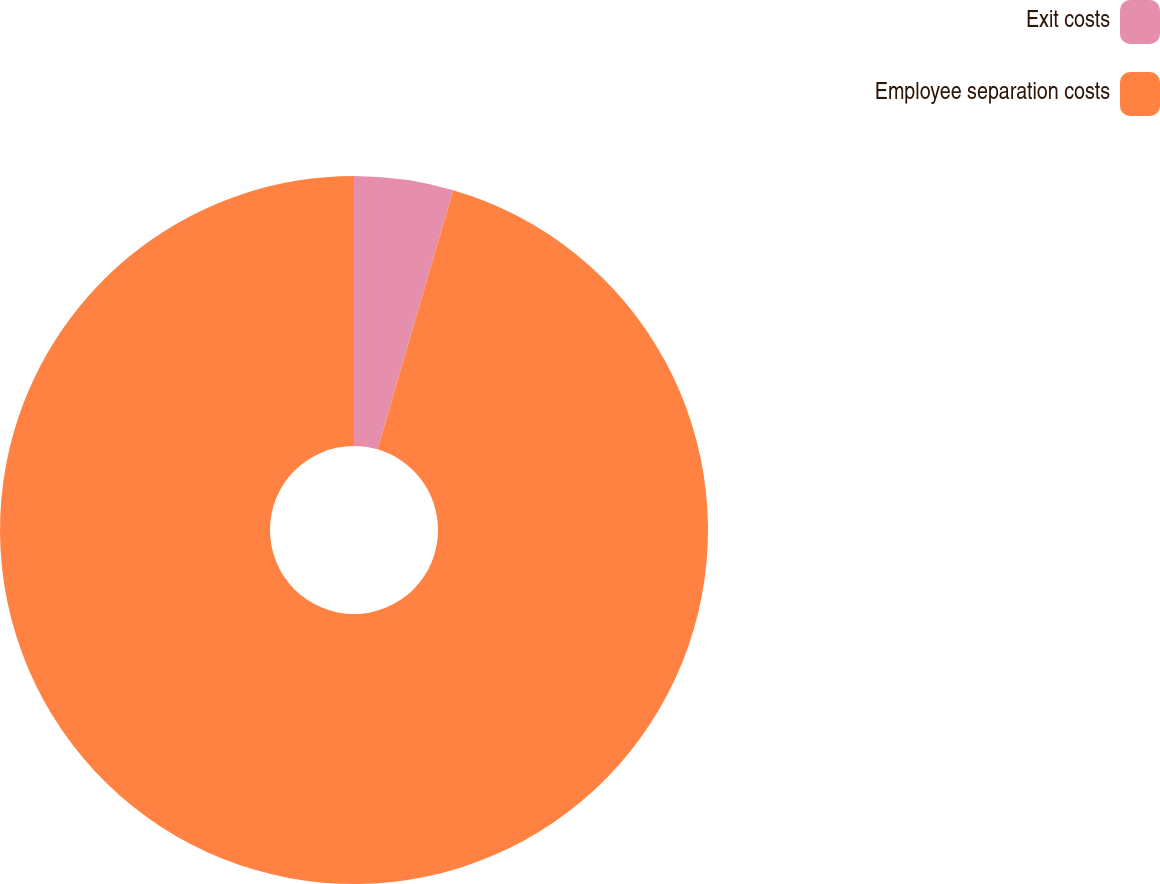Convert chart to OTSL. <chart><loc_0><loc_0><loc_500><loc_500><pie_chart><fcel>Exit costs<fcel>Employee separation costs<nl><fcel>4.52%<fcel>95.48%<nl></chart> 